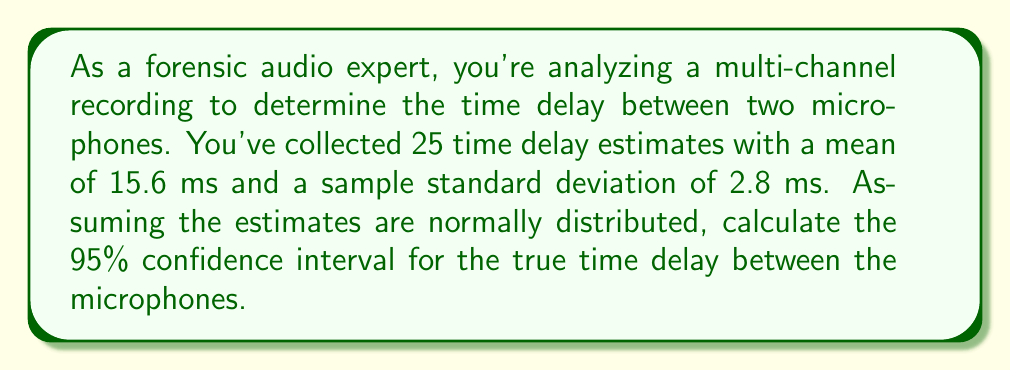Give your solution to this math problem. To calculate the confidence interval, we'll follow these steps:

1) The formula for a confidence interval is:

   $$\bar{x} \pm t_{\alpha/2, n-1} \cdot \frac{s}{\sqrt{n}}$$

   where $\bar{x}$ is the sample mean, $s$ is the sample standard deviation, $n$ is the sample size, and $t_{\alpha/2, n-1}$ is the t-value for a two-tailed test with $n-1$ degrees of freedom.

2) We have:
   $\bar{x} = 15.6$ ms
   $s = 2.8$ ms
   $n = 25$
   Confidence level = 95%, so $\alpha = 0.05$

3) Degrees of freedom: $df = n - 1 = 24$

4) From a t-table or calculator, we find $t_{0.025, 24} \approx 2.064$

5) Calculate the margin of error:

   $$2.064 \cdot \frac{2.8}{\sqrt{25}} \approx 1.16$$

6) The confidence interval is therefore:

   $$15.6 \pm 1.16$$

7) This gives us the interval (14.44, 16.76)
Answer: (14.44 ms, 16.76 ms) 